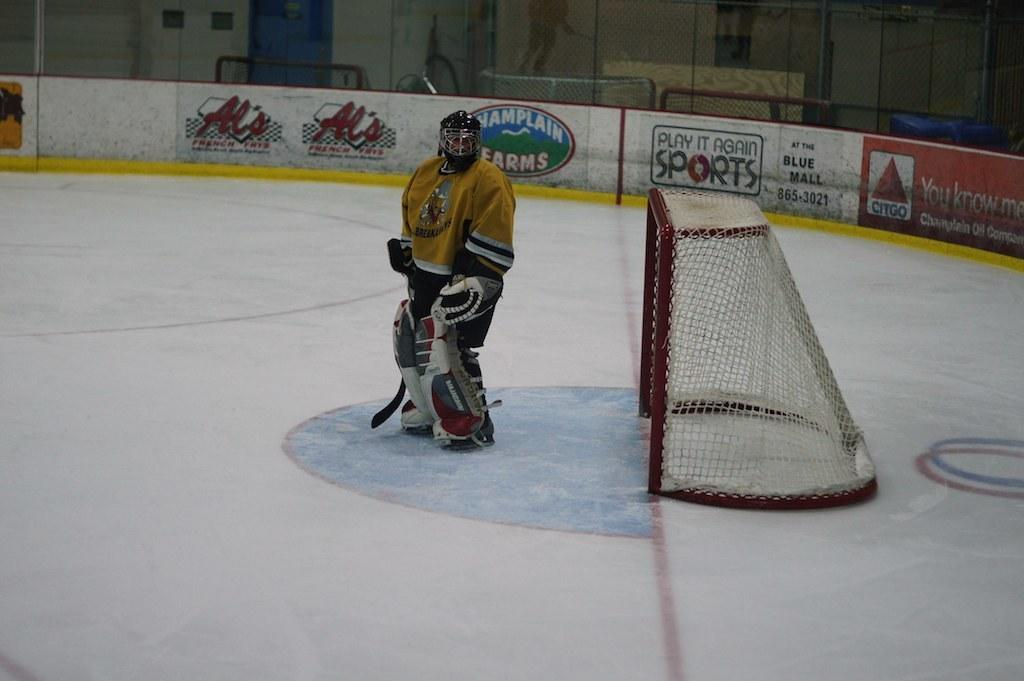What is the primary subject in the image? There is a person standing in the image. Where is the person standing? The person is standing on the floor. What sports-related object can be seen in the image? There is a football net in the image. Can you describe any artwork in the image? There is a wall with a painting in the image. What architectural feature is present in the image? There is a door in the image. What type of barrier is visible in the image? There is a fence in the image. What other structural element can be seen in the image? There is a wall in the image. What type of pen is the person holding in the image? There is no pen visible in the image. Is there a letter being written or read by the person in the image? There is no letter present in the image. 